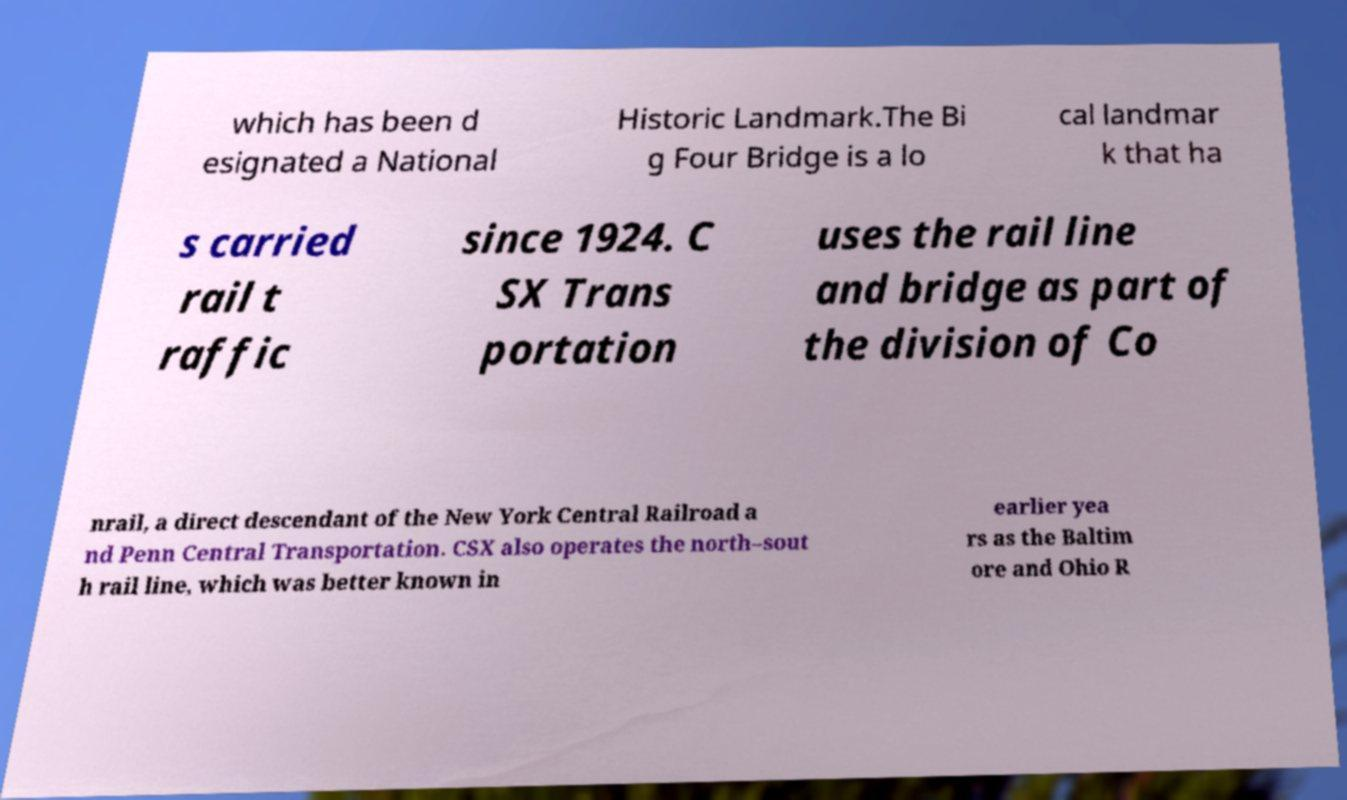I need the written content from this picture converted into text. Can you do that? which has been d esignated a National Historic Landmark.The Bi g Four Bridge is a lo cal landmar k that ha s carried rail t raffic since 1924. C SX Trans portation uses the rail line and bridge as part of the division of Co nrail, a direct descendant of the New York Central Railroad a nd Penn Central Transportation. CSX also operates the north–sout h rail line, which was better known in earlier yea rs as the Baltim ore and Ohio R 